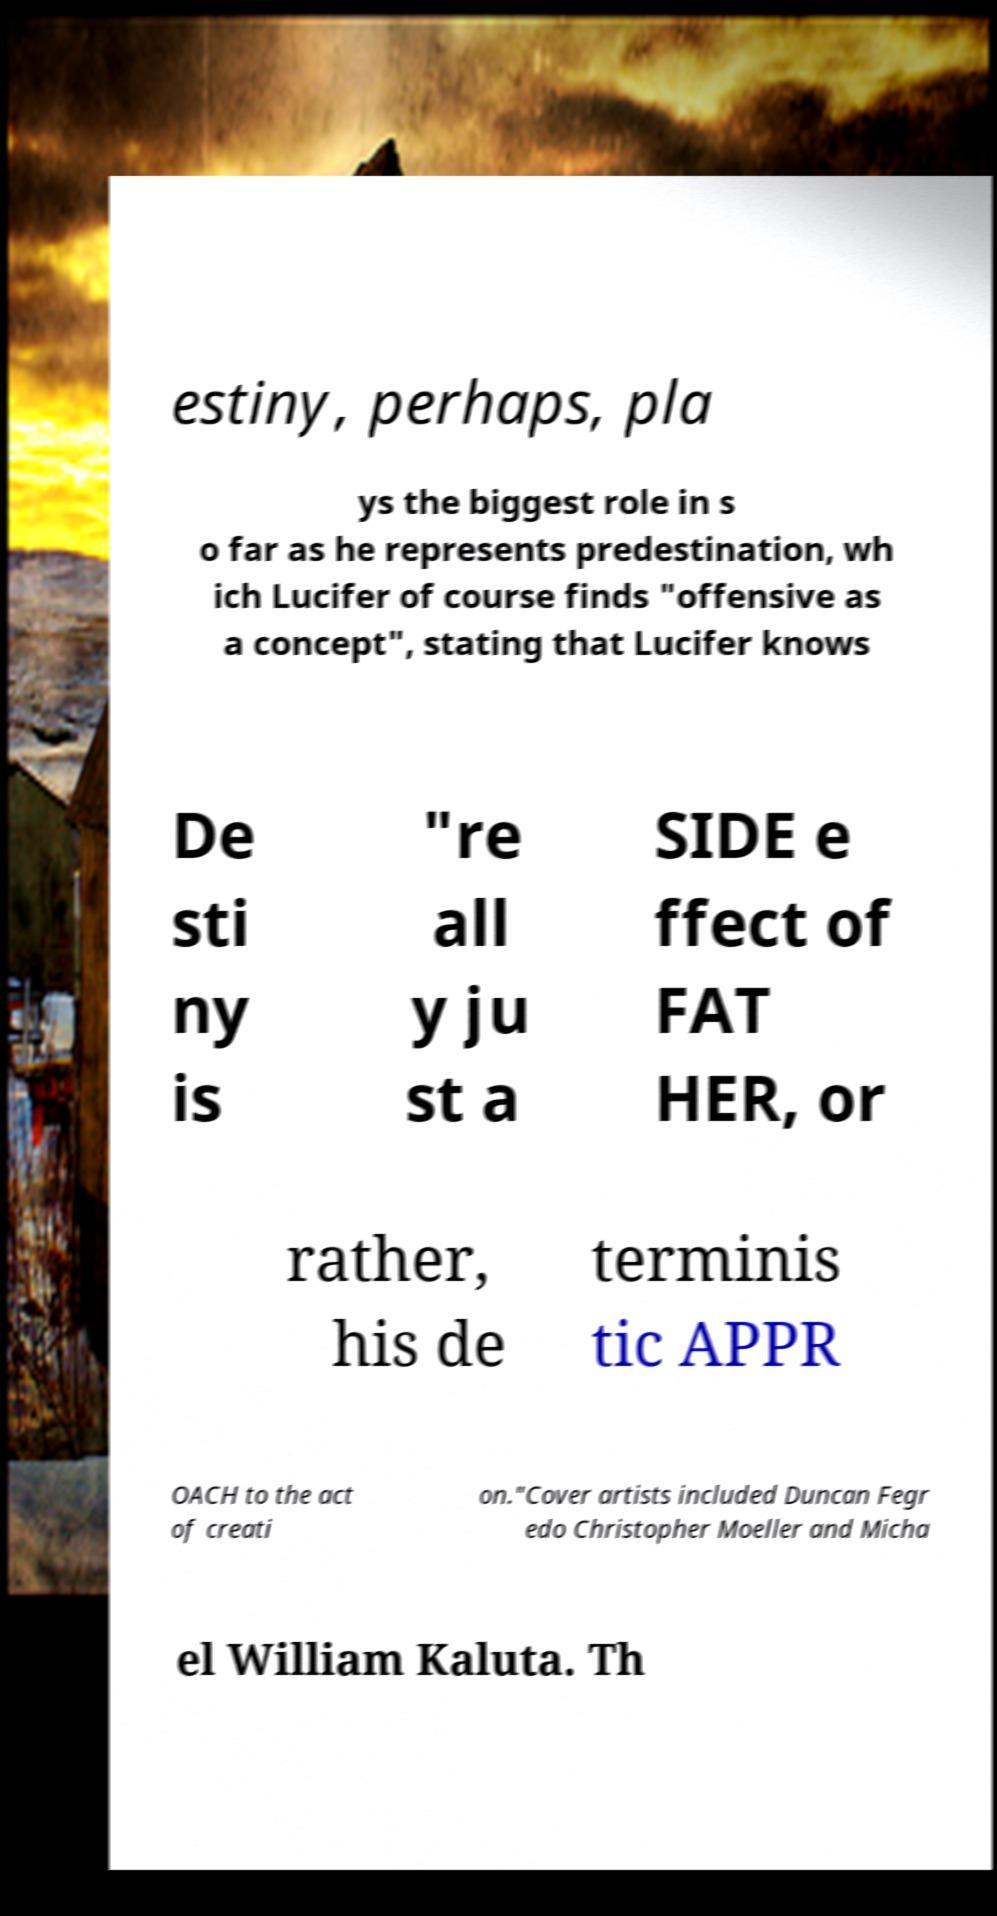There's text embedded in this image that I need extracted. Can you transcribe it verbatim? estiny, perhaps, pla ys the biggest role in s o far as he represents predestination, wh ich Lucifer of course finds "offensive as a concept", stating that Lucifer knows De sti ny is "re all y ju st a SIDE e ffect of FAT HER, or rather, his de terminis tic APPR OACH to the act of creati on."Cover artists included Duncan Fegr edo Christopher Moeller and Micha el William Kaluta. Th 